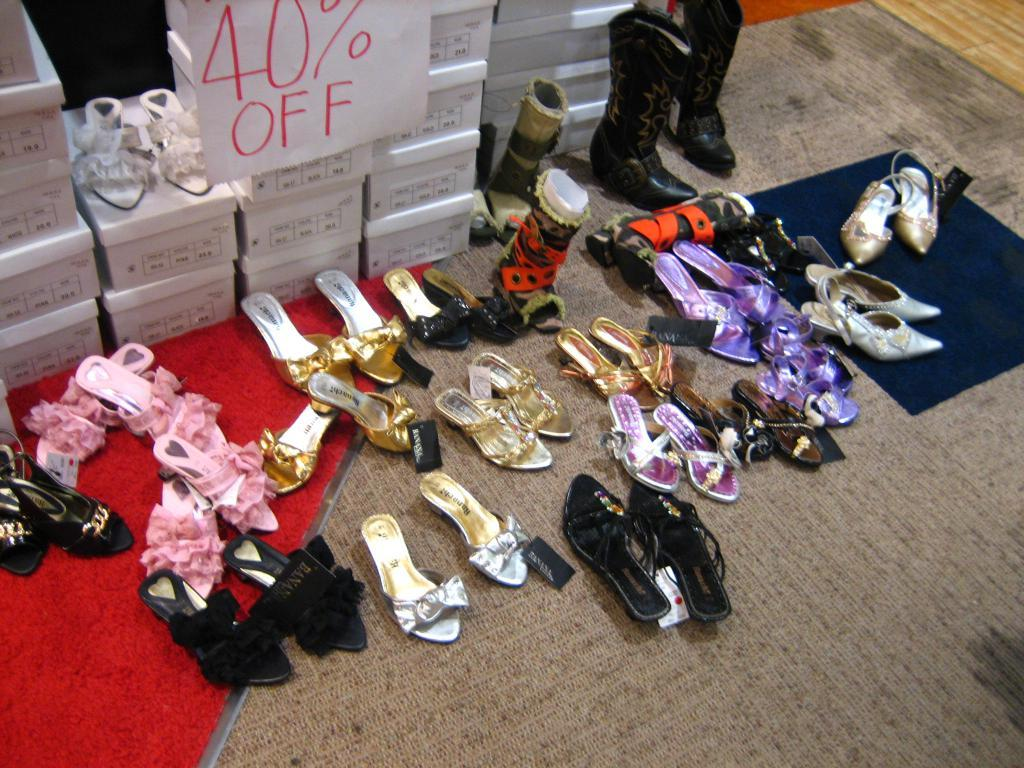What is the main subject in the center of the image? There are footwear in the center of the image. What is the footwear placed on? The footwear is on a rug. What else can be seen at the top side of the image? There are boxes at the top side of the image. Can you tell me how many horses are visible in the image? There are no horses present in the image. What type of furniture is shown in the image? There is no furniture shown in the image; only footwear, a rug, and boxes are present. 